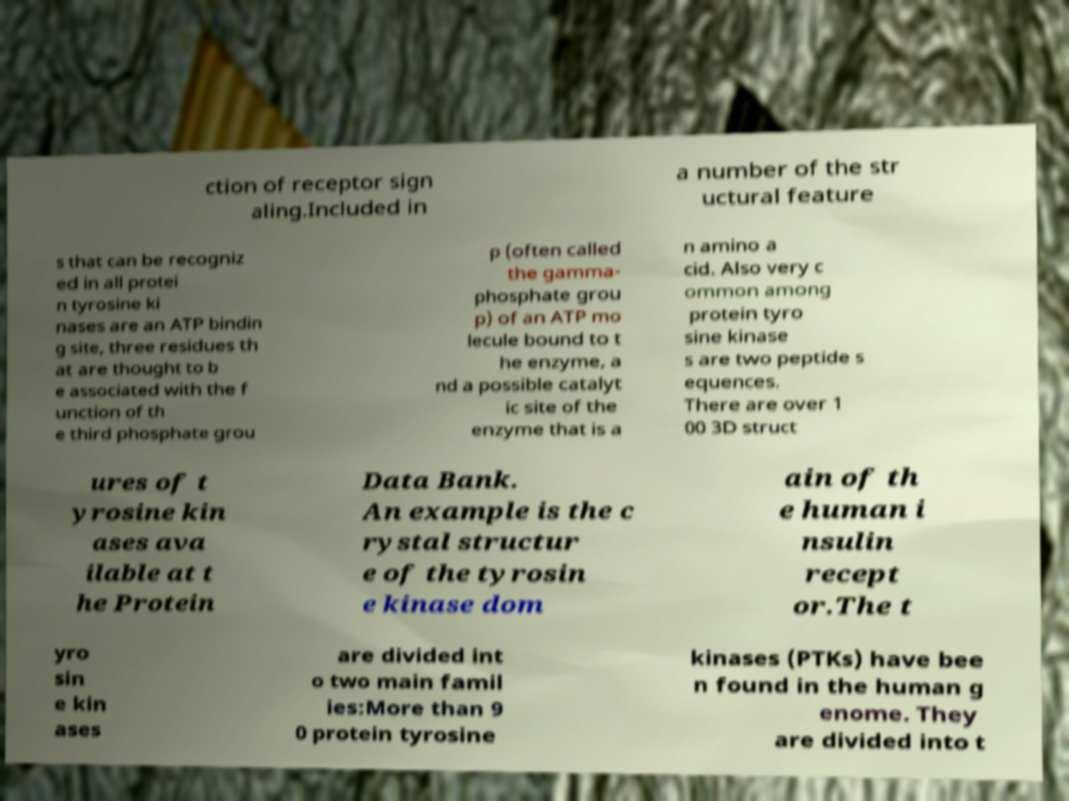Please identify and transcribe the text found in this image. ction of receptor sign aling.Included in a number of the str uctural feature s that can be recogniz ed in all protei n tyrosine ki nases are an ATP bindin g site, three residues th at are thought to b e associated with the f unction of th e third phosphate grou p (often called the gamma- phosphate grou p) of an ATP mo lecule bound to t he enzyme, a nd a possible catalyt ic site of the enzyme that is a n amino a cid. Also very c ommon among protein tyro sine kinase s are two peptide s equences. There are over 1 00 3D struct ures of t yrosine kin ases ava ilable at t he Protein Data Bank. An example is the c rystal structur e of the tyrosin e kinase dom ain of th e human i nsulin recept or.The t yro sin e kin ases are divided int o two main famil ies:More than 9 0 protein tyrosine kinases (PTKs) have bee n found in the human g enome. They are divided into t 